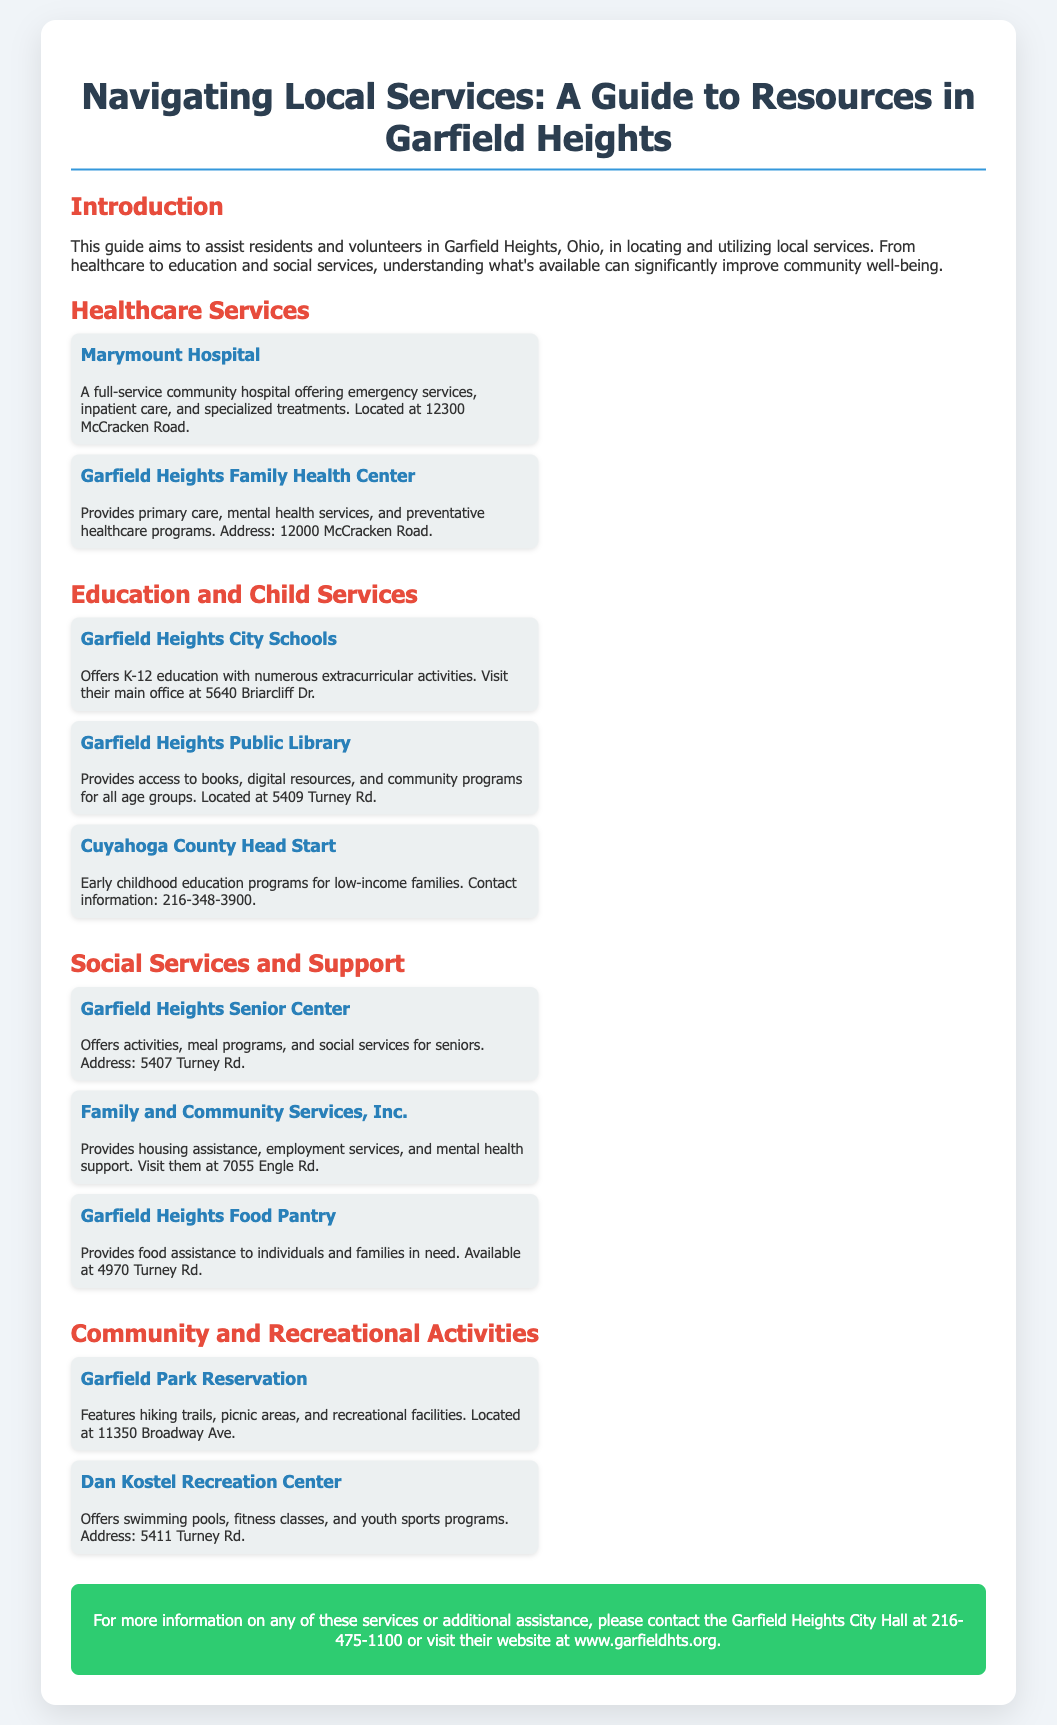What is the purpose of this guide? The guide aims to assist residents and volunteers in Garfield Heights in locating and utilizing local services.
Answer: To assist residents and volunteers in Garfield Heights Where is Marymount Hospital located? The address for Marymount Hospital is specified in the document as 12300 McCracken Road.
Answer: 12300 McCracken Road What type of services does Garfield Heights Family Health Center provide? The document states that they provide primary care, mental health services, and preventative healthcare programs.
Answer: Primary care, mental health services, and preventative healthcare programs What is the contact number for Cuyahoga County Head Start? The document provides the contact number for Cuyahoga County Head Start as 216-348-3900.
Answer: 216-348-3900 What activities does the Garfield Heights Senior Center offer? The document mentions that the Garfield Heights Senior Center offers activities, meal programs, and social services for seniors.
Answer: Activities, meal programs, and social services Which facility offers sports programs? The Dan Kostel Recreation Center provides youth sports programs according to the document.
Answer: Dan Kostel Recreation Center What is the address of the Garfield Heights Food Pantry? The address listed for the Garfield Heights Food Pantry in the document is 4970 Turney Rd.
Answer: 4970 Turney Rd Name one recreational feature at Garfield Park Reservation. The document states that Garfield Park Reservation features hiking trails.
Answer: Hiking trails 